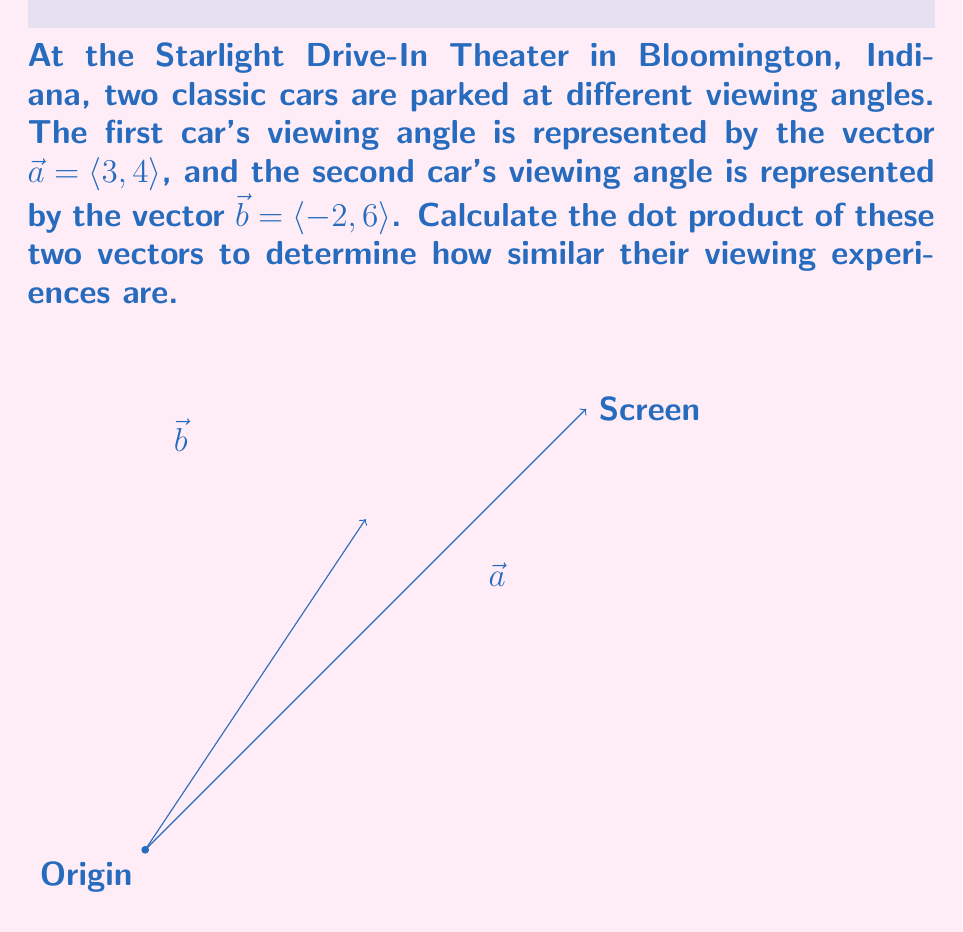What is the answer to this math problem? To compute the dot product of two vectors $\vec{a} = \langle a_1, a_2 \rangle$ and $\vec{b} = \langle b_1, b_2 \rangle$, we use the formula:

$$\vec{a} \cdot \vec{b} = a_1b_1 + a_2b_2$$

Given:
$\vec{a} = \langle 3, 4 \rangle$
$\vec{b} = \langle -2, 6 \rangle$

Step 1: Multiply the corresponding components
$a_1b_1 = 3 \times (-2) = -6$
$a_2b_2 = 4 \times 6 = 24$

Step 2: Add the results
$\vec{a} \cdot \vec{b} = (-6) + 24 = 18$

The positive result indicates that the viewing angles are somewhat similar, as they are pointing in generally the same direction (towards the screen).
Answer: $18$ 